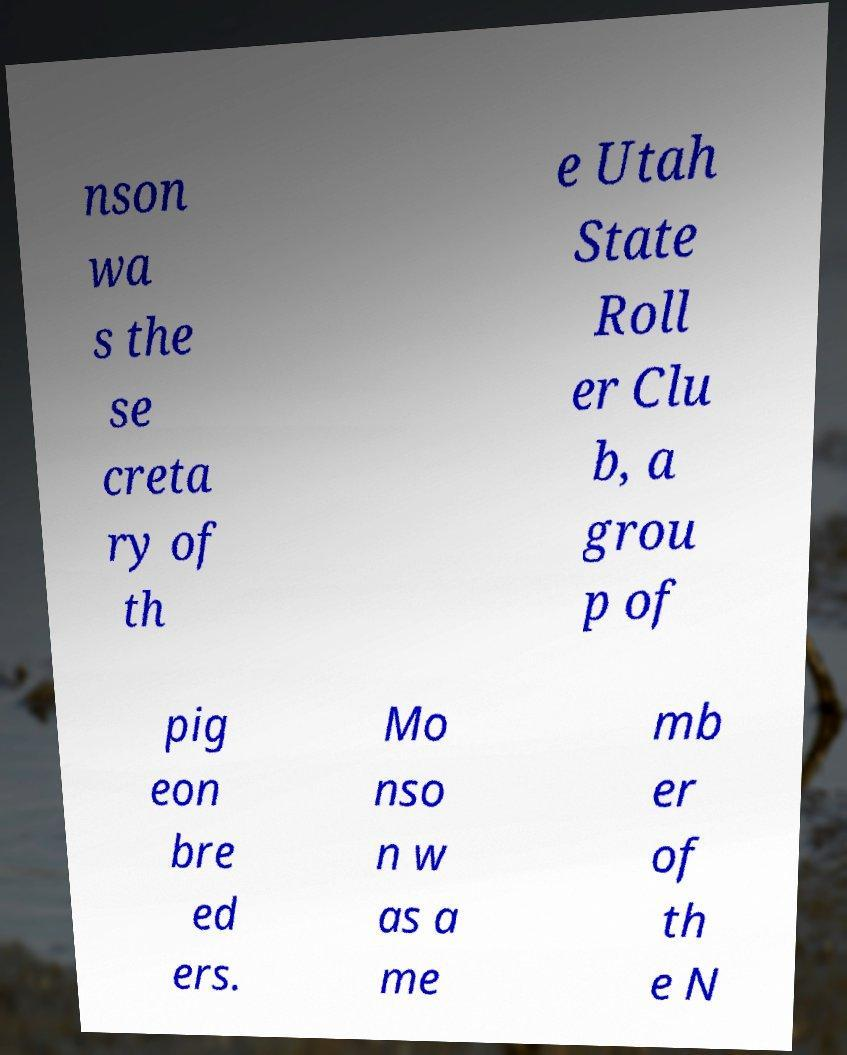There's text embedded in this image that I need extracted. Can you transcribe it verbatim? nson wa s the se creta ry of th e Utah State Roll er Clu b, a grou p of pig eon bre ed ers. Mo nso n w as a me mb er of th e N 